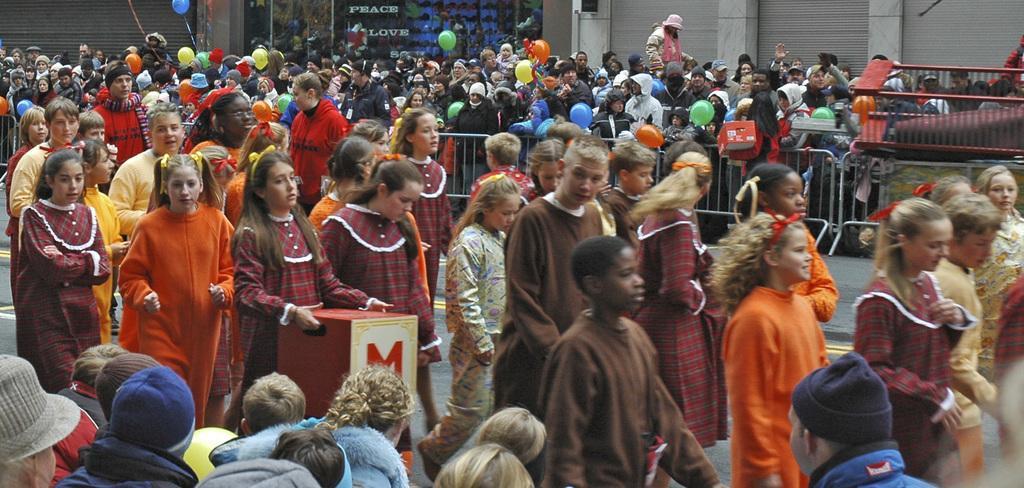Please provide a concise description of this image. In this image, we can see a crowd standing and wearing clothes. There is a person holding a box with her hand. There is a barricade in the middle of the image. There are some persons holding balloons. 